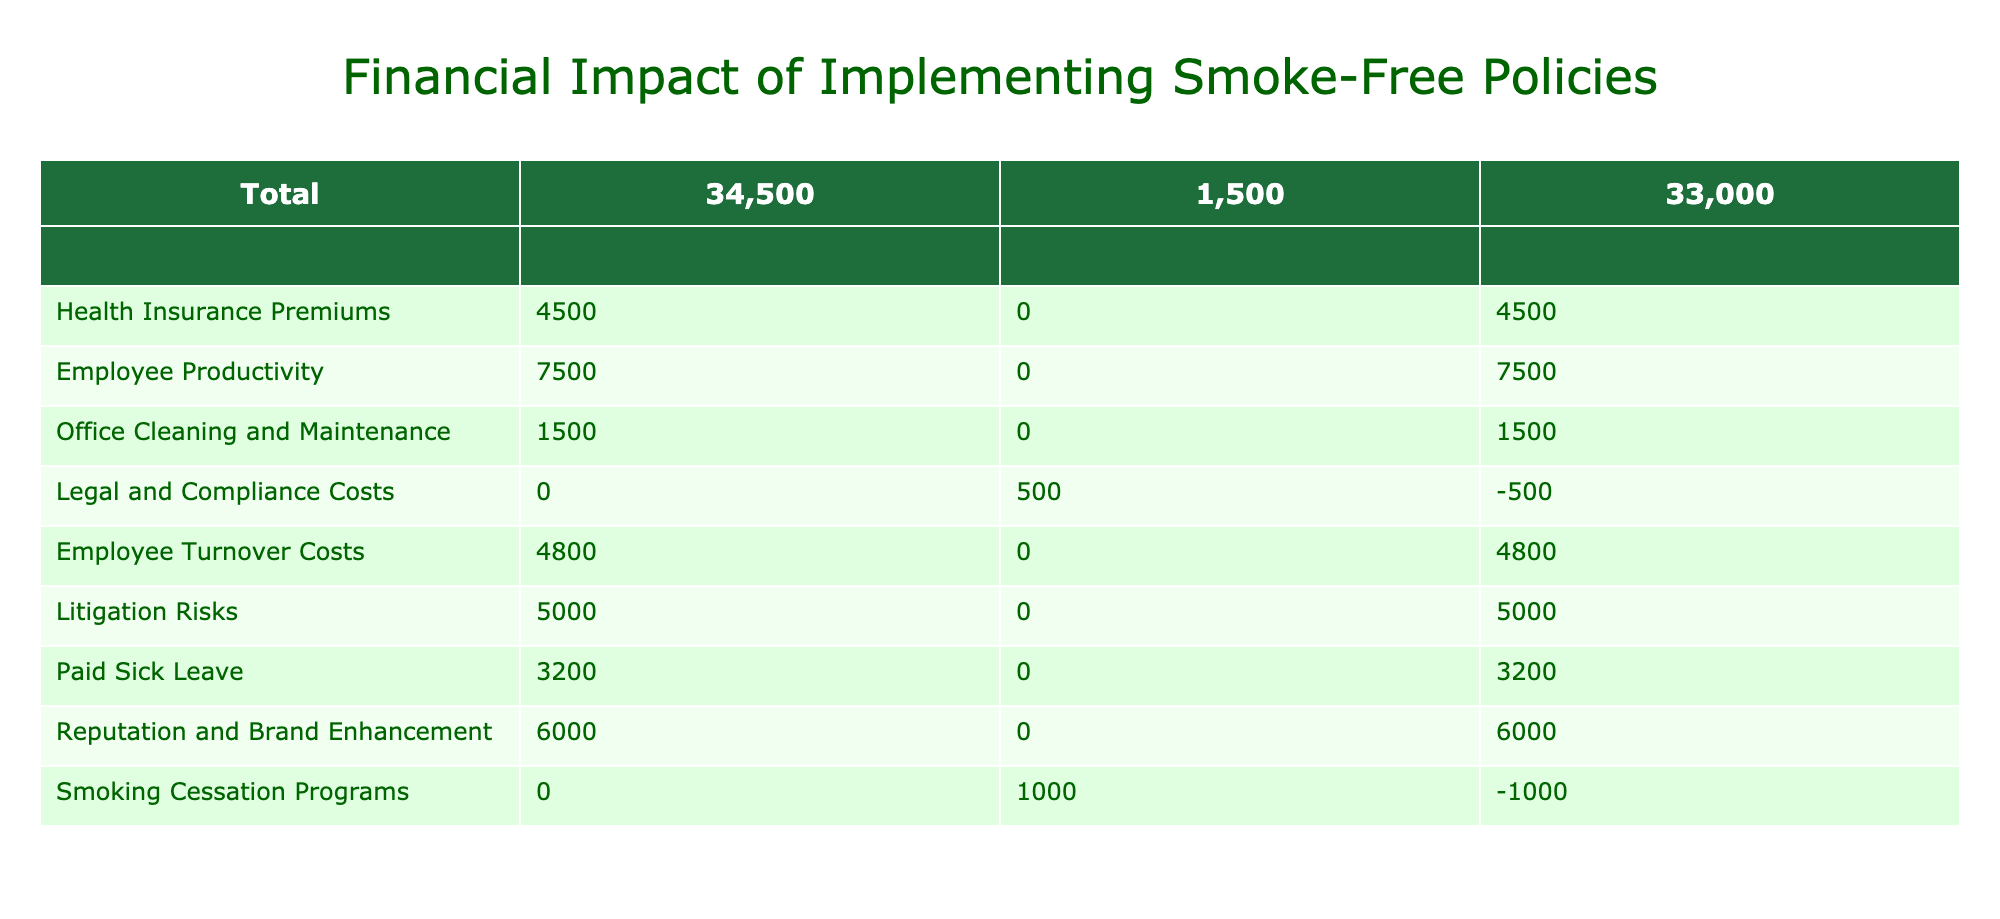What is the total cost savings from implementing the smoke-free policy? To find the total cost savings, we sum the values listed in the Cost Savings column. These values are 2000 + 4500 + 7500 + 1500 + 4800 + 5000 + 3200 + 6000, which equals 31,500.
Answer: 31,500 What is the net financial impact from office cleaning and maintenance? The net financial impact for office cleaning and maintenance is directly given in the table under the Net Financial Impact column, which is 1500.
Answer: 1500 Did the implementation of smoke-free policies incur any additional costs? Yes, there are additional costs associated with legal and compliance costs (500) and smoking cessation programs (1000), which confirms that there were additional costs.
Answer: Yes What is the net financial impact for implementing smoke-free policies in terms of health insurance premiums? The net financial impact for health insurance premiums is listed directly in the table as 4500.
Answer: 4500 What is the total of additional costs incurred due to implementing the smoke-free policy? To find the total additional costs, we add the values in the Additional Costs column. There is only one value listed (500) besides the smoking cessation programs (1000), making the total additional costs 500 + 1000 = 1500.
Answer: 1500 Which entity has the highest net financial impact after implementing the smoke-free policy? By comparing the Net Financial Impact column values, the highest negative value is from legal and compliance costs (-500), while the highest positive one is from Employee Productivity (7500), making the highest net financial impact 7500.
Answer: 7500 What is the difference between the total cost savings and total additional costs? The total cost savings is 31500, while the total additional costs is 1500, so the difference would be 31500 - 1500 = 30000.
Answer: 30000 Is there any entity with a negative net financial impact? Yes, both legal and compliance costs (-500) and smoking cessation programs (-1000) have negative net financial impacts, confirming that both entities did not generate enough savings to cover their costs.
Answer: Yes 